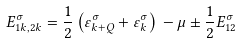<formula> <loc_0><loc_0><loc_500><loc_500>E _ { 1 { k } , 2 k } ^ { \sigma } = \frac { 1 } { 2 } \left ( \varepsilon ^ { \sigma } _ { k + Q } + \varepsilon ^ { \sigma } _ { k } \right ) { } - \mu \pm \frac { 1 } { 2 } E ^ { \sigma } _ { 1 2 }</formula> 